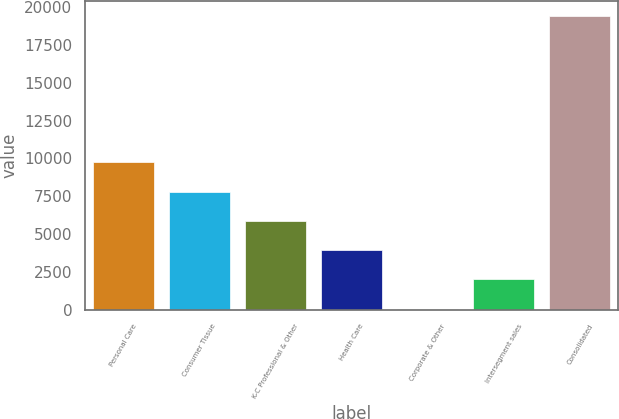Convert chart. <chart><loc_0><loc_0><loc_500><loc_500><bar_chart><fcel>Personal Care<fcel>Consumer Tissue<fcel>K-C Professional & Other<fcel>Health Care<fcel>Corporate & Other<fcel>Intersegment sales<fcel>Consolidated<nl><fcel>9747<fcel>7813.4<fcel>5879.8<fcel>3946.2<fcel>79<fcel>2012.6<fcel>19415<nl></chart> 